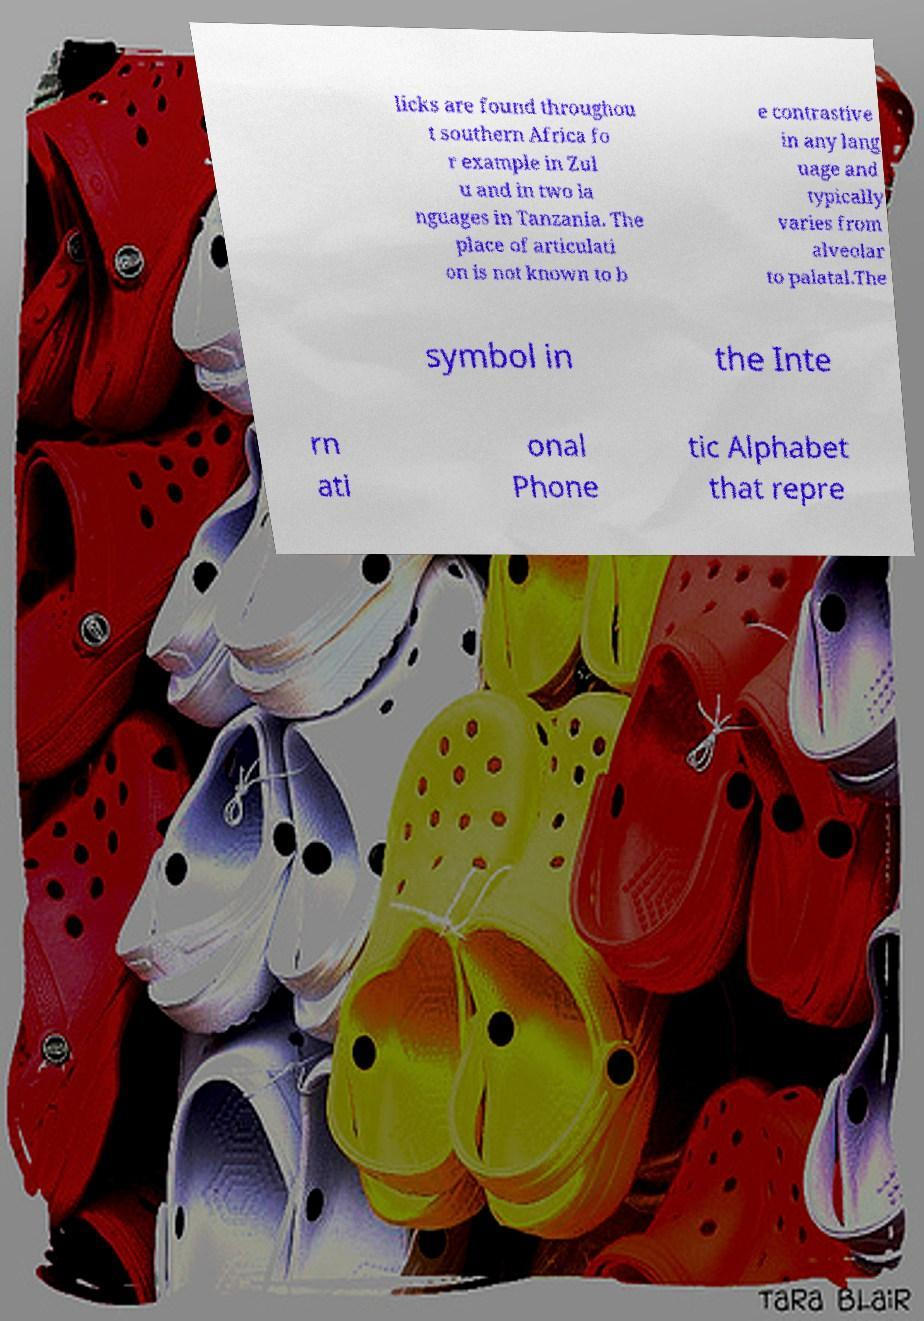Can you read and provide the text displayed in the image?This photo seems to have some interesting text. Can you extract and type it out for me? licks are found throughou t southern Africa fo r example in Zul u and in two la nguages in Tanzania. The place of articulati on is not known to b e contrastive in any lang uage and typically varies from alveolar to palatal.The symbol in the Inte rn ati onal Phone tic Alphabet that repre 